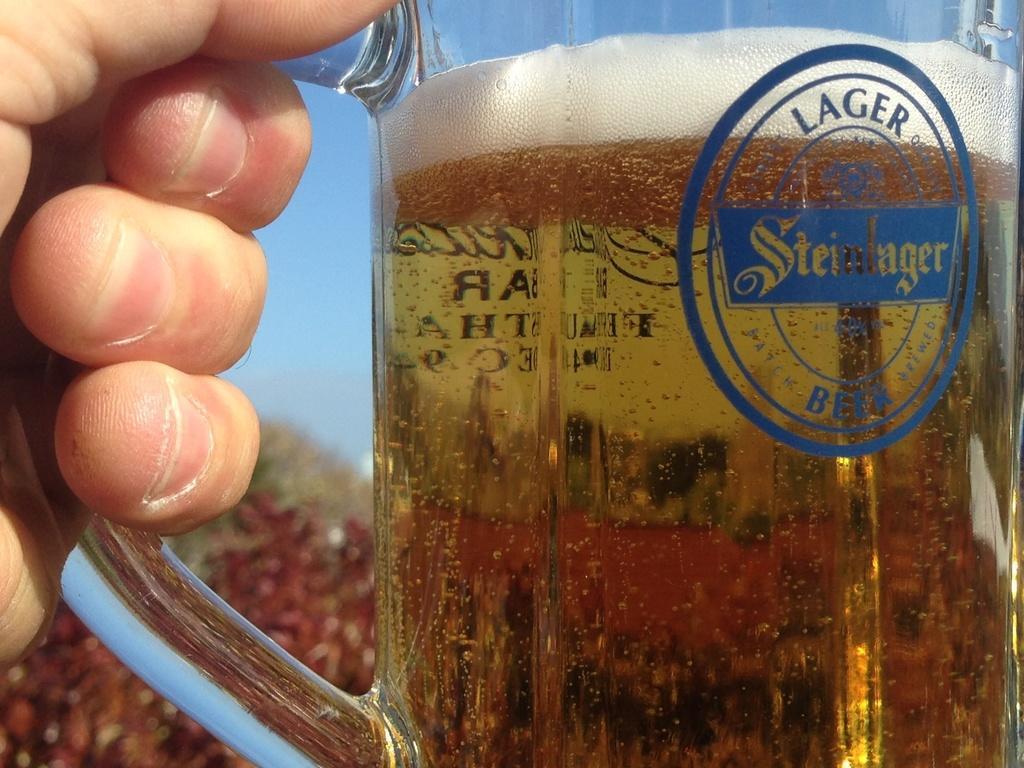Describe this image in one or two sentences. In this image in the foreground there is one person who is holding a glass, in that glass there is some drink. In the background there are plants and sky. 